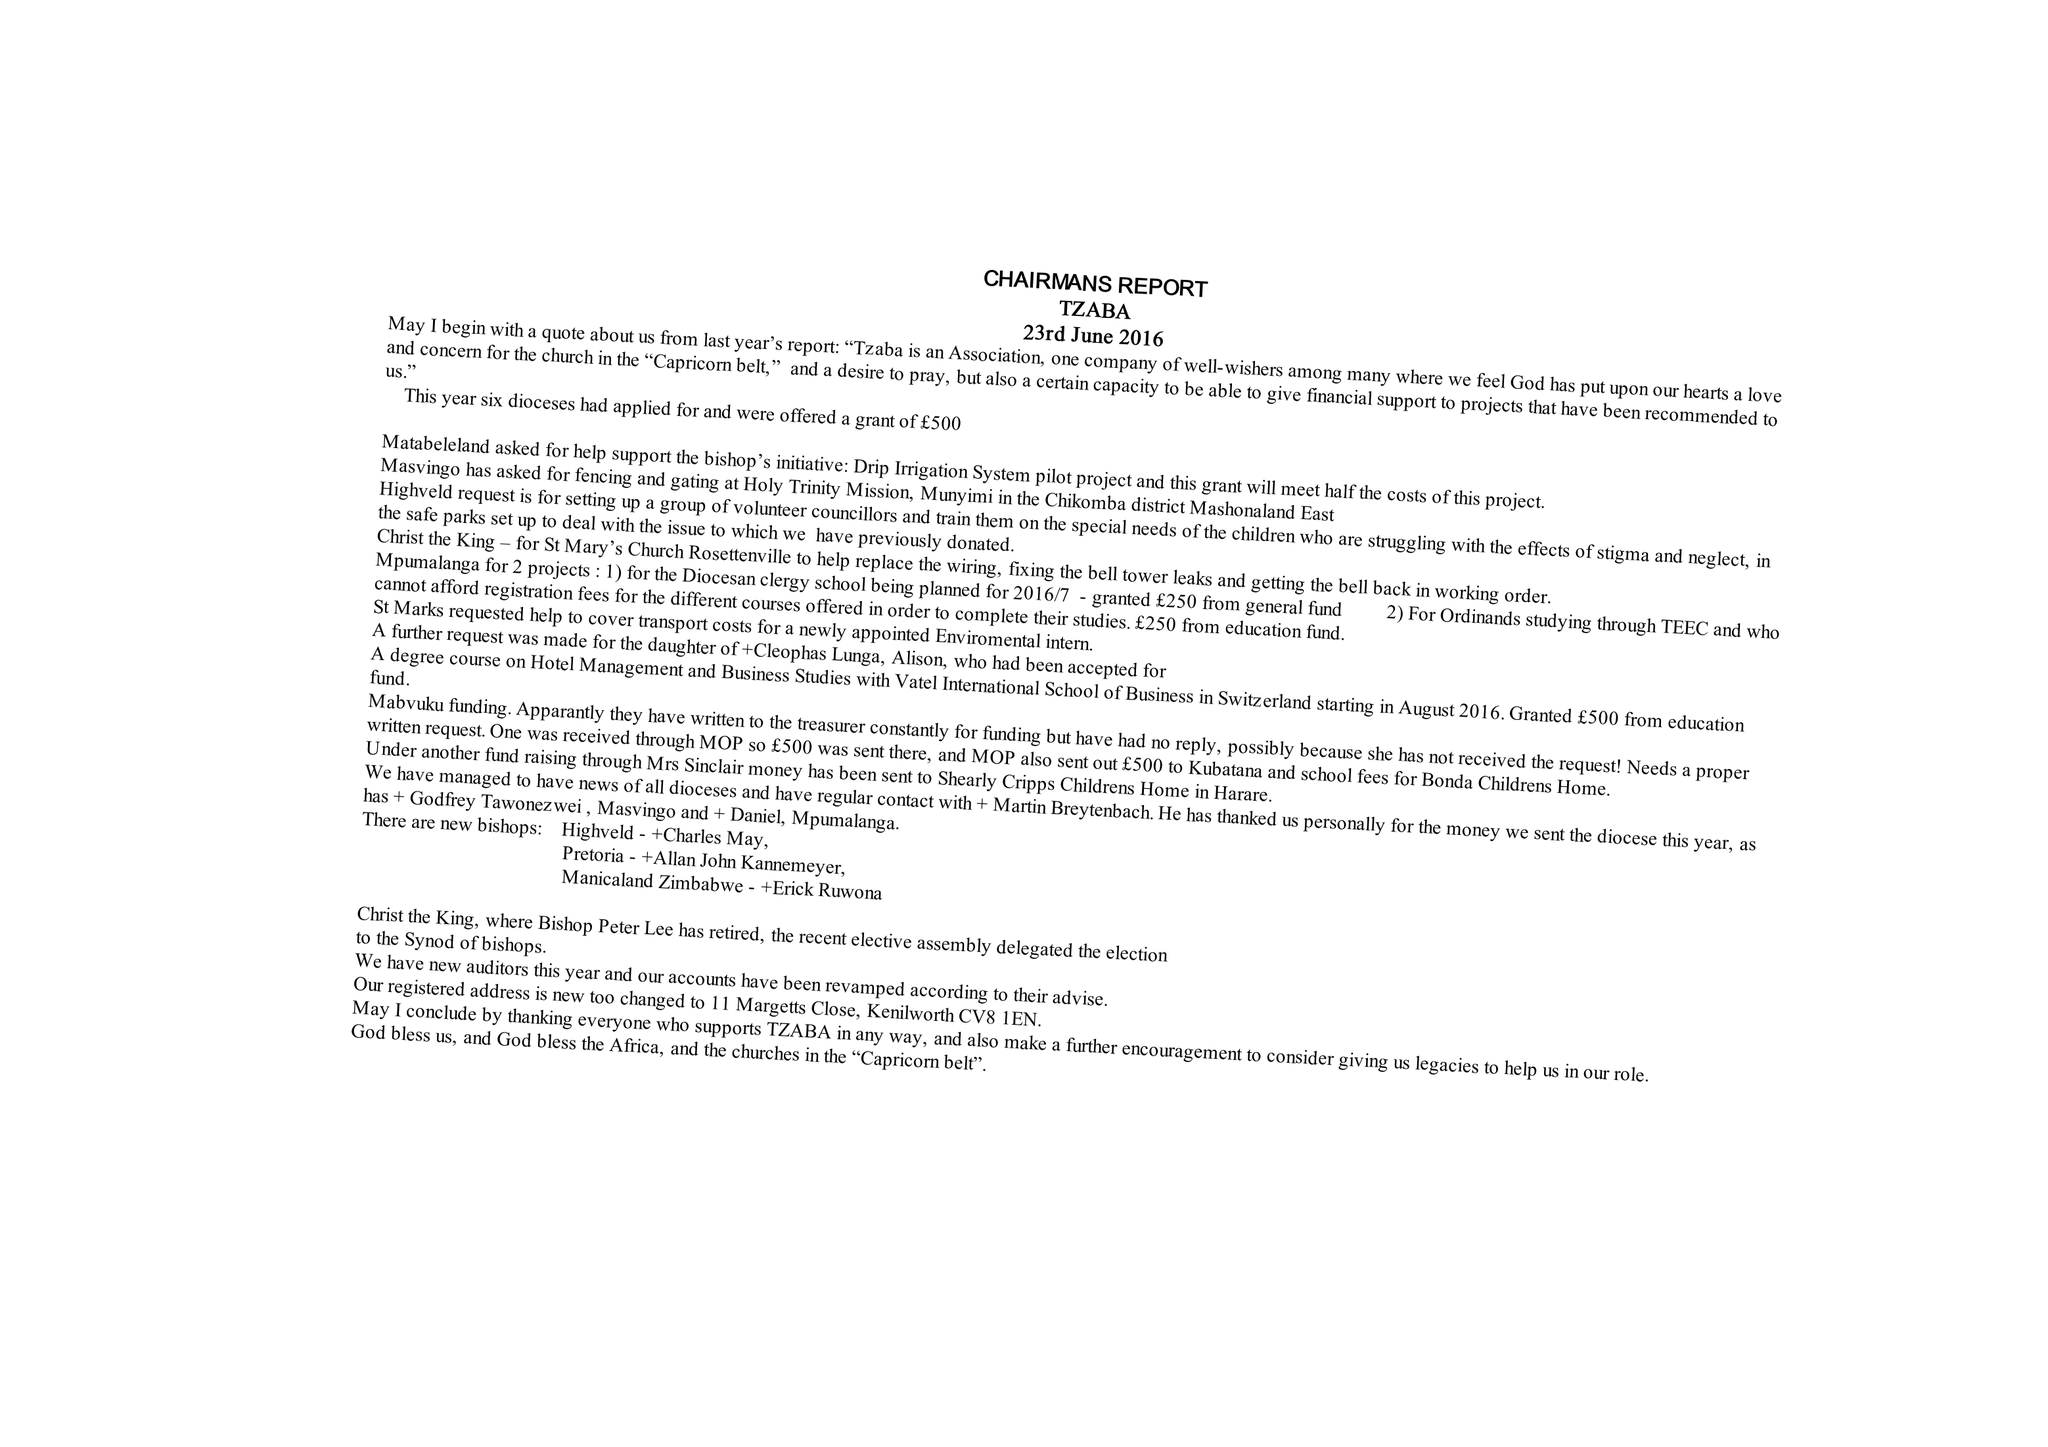What is the value for the address__post_town?
Answer the question using a single word or phrase. KENILWORTH 